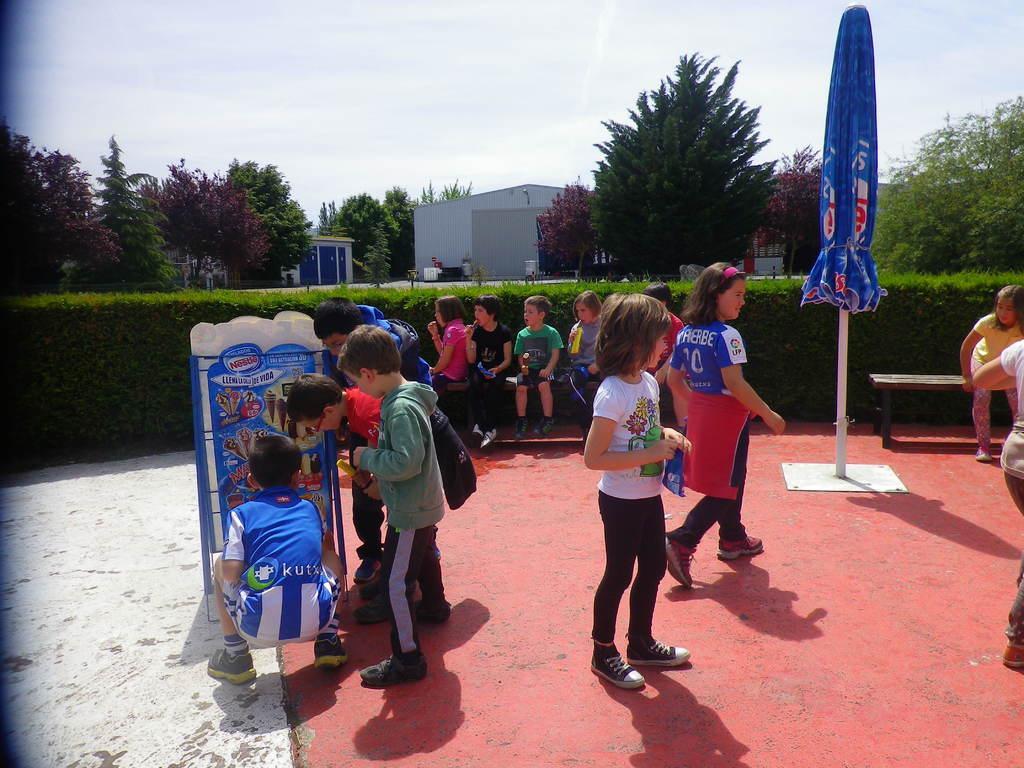In one or two sentences, can you explain what this image depicts? In this image we can see children are standing on the floor. On the right side of the image, we can see a girl, umbrella and bench. In the background, we can see the children are sitting on the bench. Behind them, we can see plants, trees and buildings. At the top of the image, we can see the sky. 